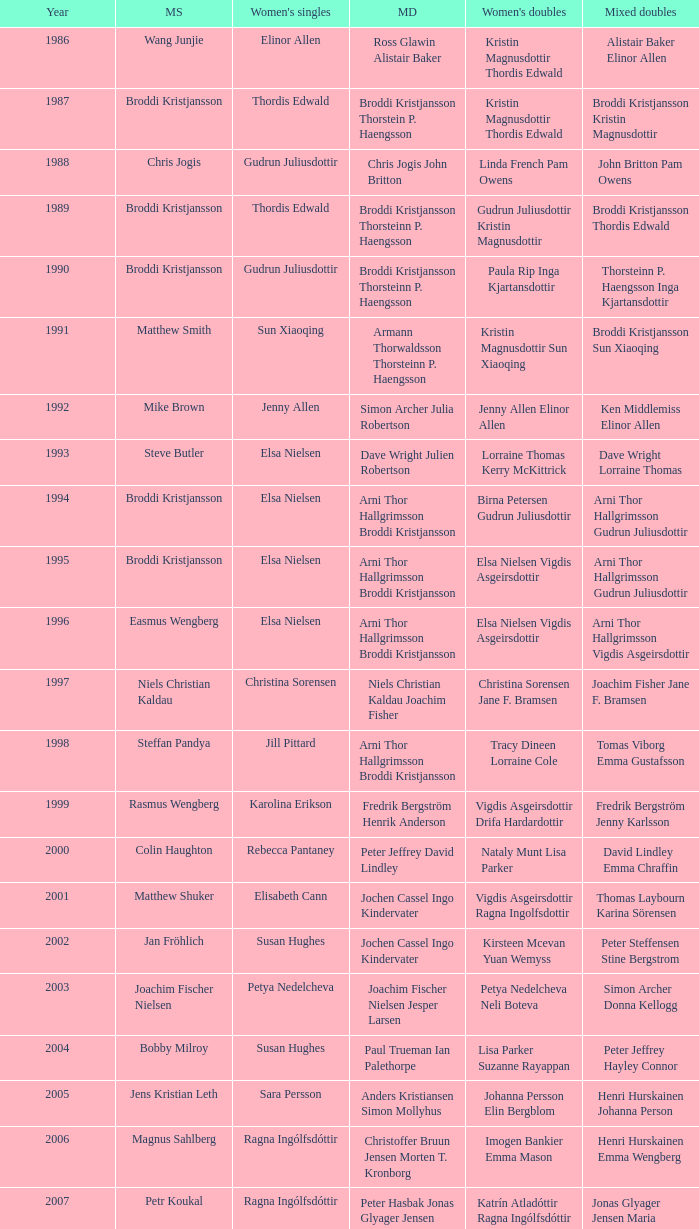In what mixed doubles did Niels Christian Kaldau play in men's singles? Joachim Fisher Jane F. Bramsen. 